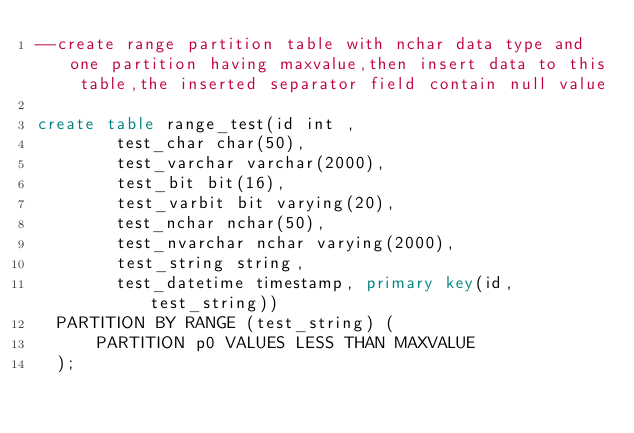Convert code to text. <code><loc_0><loc_0><loc_500><loc_500><_SQL_>--create range partition table with nchar data type and one partition having maxvalue,then insert data to this table,the inserted separator field contain null value

create table range_test(id int ,
				test_char char(50),
				test_varchar varchar(2000),
				test_bit bit(16),
				test_varbit bit varying(20),
				test_nchar nchar(50),
				test_nvarchar nchar varying(2000),
				test_string string,
				test_datetime timestamp, primary key(id,test_string))
	PARTITION BY RANGE (test_string) (
	    PARTITION p0 VALUES LESS THAN MAXVALUE
	);</code> 